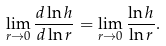<formula> <loc_0><loc_0><loc_500><loc_500>\lim _ { r \rightarrow 0 } \frac { d \ln h } { d \ln r } = \lim _ { r \rightarrow 0 } \frac { \ln h } { \ln r } .</formula> 